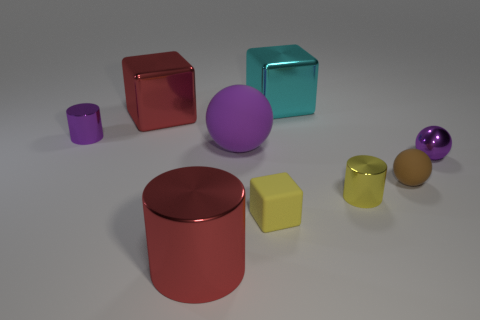Subtract 1 cylinders. How many cylinders are left? 2 Subtract all shiny spheres. How many spheres are left? 2 Subtract all cylinders. How many objects are left? 6 Subtract all blue cylinders. Subtract all purple spheres. How many cylinders are left? 3 Add 4 metal things. How many metal things are left? 10 Add 9 tiny yellow cubes. How many tiny yellow cubes exist? 10 Subtract 0 green spheres. How many objects are left? 9 Subtract all tiny purple things. Subtract all big purple spheres. How many objects are left? 6 